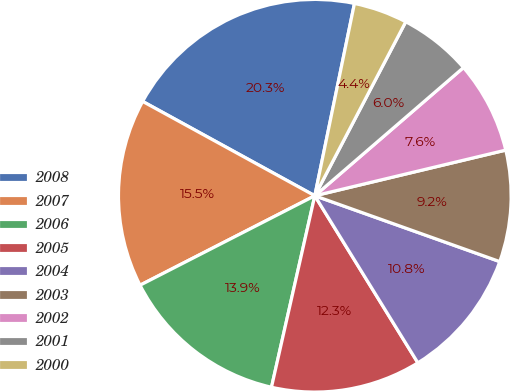Convert chart to OTSL. <chart><loc_0><loc_0><loc_500><loc_500><pie_chart><fcel>2008<fcel>2007<fcel>2006<fcel>2005<fcel>2004<fcel>2003<fcel>2002<fcel>2001<fcel>2000<nl><fcel>20.26%<fcel>15.51%<fcel>13.93%<fcel>12.34%<fcel>10.76%<fcel>9.18%<fcel>7.59%<fcel>6.01%<fcel>4.43%<nl></chart> 